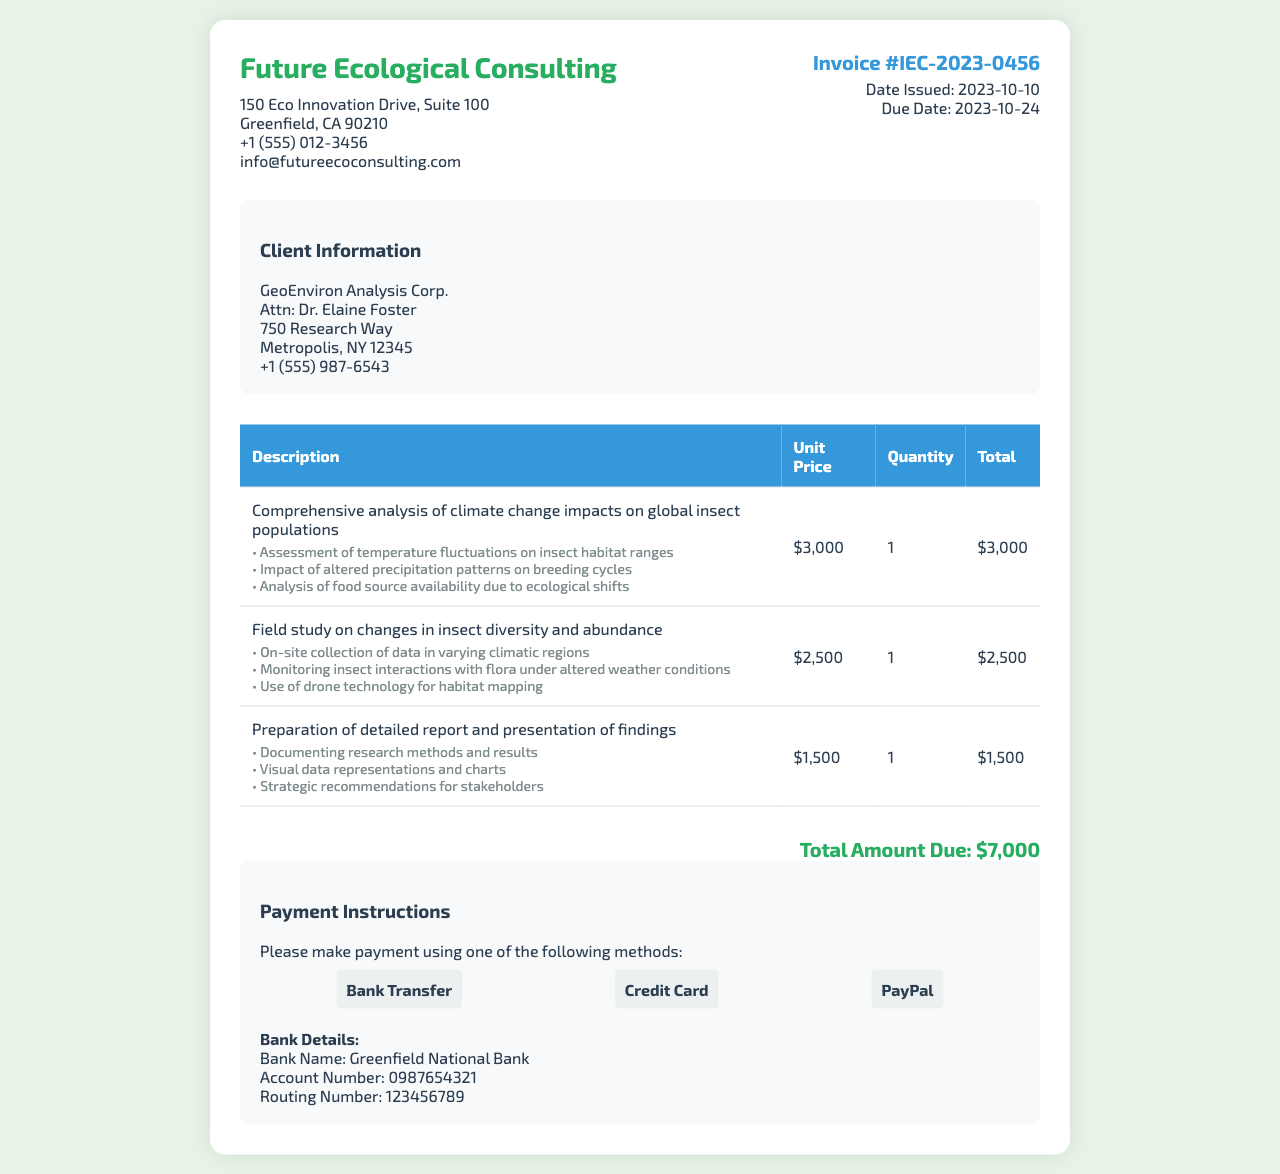What is the invoice number? The invoice number is stated near the top of the document, which identifies this specific invoice as IEC-2023-0456.
Answer: IEC-2023-0456 What is the total amount due? The total amount due is listed at the bottom of the invoice summarizing all services provided, which amounts to $7,000.
Answer: $7,000 Who is the client representative? The document mentions Dr. Elaine Foster as the representative for the client company, GeoEnviron Analysis Corp.
Answer: Dr. Elaine Foster When is the payment due date? The due date for the payment is clearly stated in the invoice details, set for 2023-10-24.
Answer: 2023-10-24 What types of payment methods are accepted? The invoice outlines acceptable payment methods, including Bank Transfer, Credit Card, and PayPal.
Answer: Bank Transfer, Credit Card, PayPal What is included in the comprehensive analysis? The services listed describe specific assessments included in the comprehensive analysis of climate change impacts on global insect populations.
Answer: Assessment of temperature fluctuations on insect habitat ranges, Impact of altered precipitation patterns on breeding cycles, Analysis of food source availability due to ecological shifts How many services are billed in total? The invoice details three different services rendered, which means three services are billed.
Answer: 3 What is the address of Future Ecological Consulting? The address for Future Ecological Consulting can be found in the company info section of the document.
Answer: 150 Eco Innovation Drive, Suite 100, Greenfield, CA 90210 